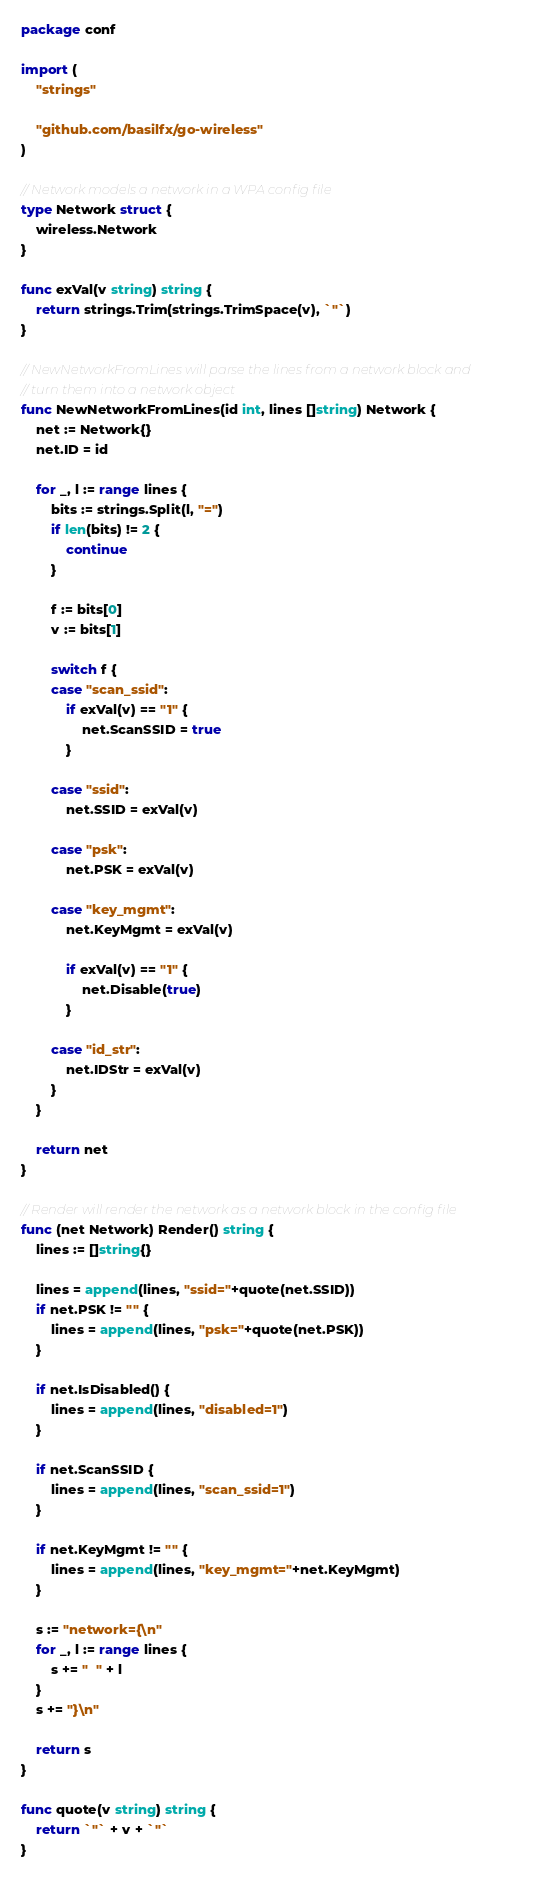<code> <loc_0><loc_0><loc_500><loc_500><_Go_>package conf

import (
	"strings"

	"github.com/basilfx/go-wireless"
)

// Network models a network in a WPA config file
type Network struct {
	wireless.Network
}

func exVal(v string) string {
	return strings.Trim(strings.TrimSpace(v), `"`)
}

// NewNetworkFromLines will parse the lines from a network block and
// turn them into a network object
func NewNetworkFromLines(id int, lines []string) Network {
	net := Network{}
	net.ID = id

	for _, l := range lines {
		bits := strings.Split(l, "=")
		if len(bits) != 2 {
			continue
		}

		f := bits[0]
		v := bits[1]

		switch f {
		case "scan_ssid":
			if exVal(v) == "1" {
				net.ScanSSID = true
			}

		case "ssid":
			net.SSID = exVal(v)

		case "psk":
			net.PSK = exVal(v)

		case "key_mgmt":
			net.KeyMgmt = exVal(v)

			if exVal(v) == "1" {
				net.Disable(true)
			}

		case "id_str":
			net.IDStr = exVal(v)
		}
	}

	return net
}

// Render will render the network as a network block in the config file
func (net Network) Render() string {
	lines := []string{}

	lines = append(lines, "ssid="+quote(net.SSID))
	if net.PSK != "" {
		lines = append(lines, "psk="+quote(net.PSK))
	}

	if net.IsDisabled() {
		lines = append(lines, "disabled=1")
	}

	if net.ScanSSID {
		lines = append(lines, "scan_ssid=1")
	}

	if net.KeyMgmt != "" {
		lines = append(lines, "key_mgmt="+net.KeyMgmt)
	}

	s := "network={\n"
	for _, l := range lines {
		s += "  " + l
	}
	s += "}\n"

	return s
}

func quote(v string) string {
	return `"` + v + `"`
}
</code> 